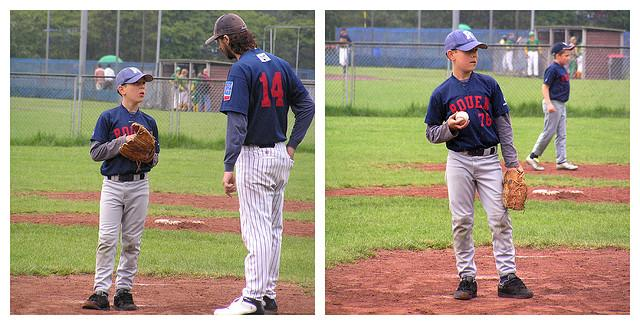What color is the text for this jersey of the boy playing baseball?

Choices:
A) white
B) red
C) blue
D) yellow red 